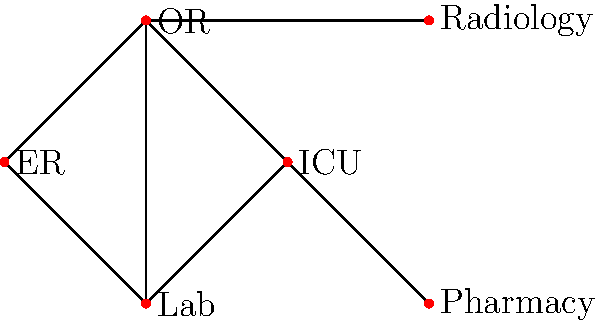In the simplified medical network diagram representing different departments in Dr. Claybrooks' hospital, what is the minimum number of departments that must be closed to completely disconnect the Emergency Room (ER) from the Intensive Care Unit (ICU)? To solve this problem, we need to analyze the connectivity between the ER and ICU departments:

1. First, identify the nodes representing ER and ICU in the diagram.
   - ER is located at the bottom left
   - ICU is located at the right side

2. Observe the possible paths between ER and ICU:
   a) ER → OR → ICU
   b) ER → Lab → OR → ICU
   c) ER → OR → Radiology → OR → ICU

3. To disconnect ER from ICU, we need to break all these paths.

4. Notice that the Operating Room (OR) is present in all paths between ER and ICU.

5. If we close the OR department, it will break all possible connections between ER and ICU.

6. No other single department can achieve this disconnection.

Therefore, closing just one department (OR) is sufficient to completely disconnect ER from ICU.
Answer: 1 